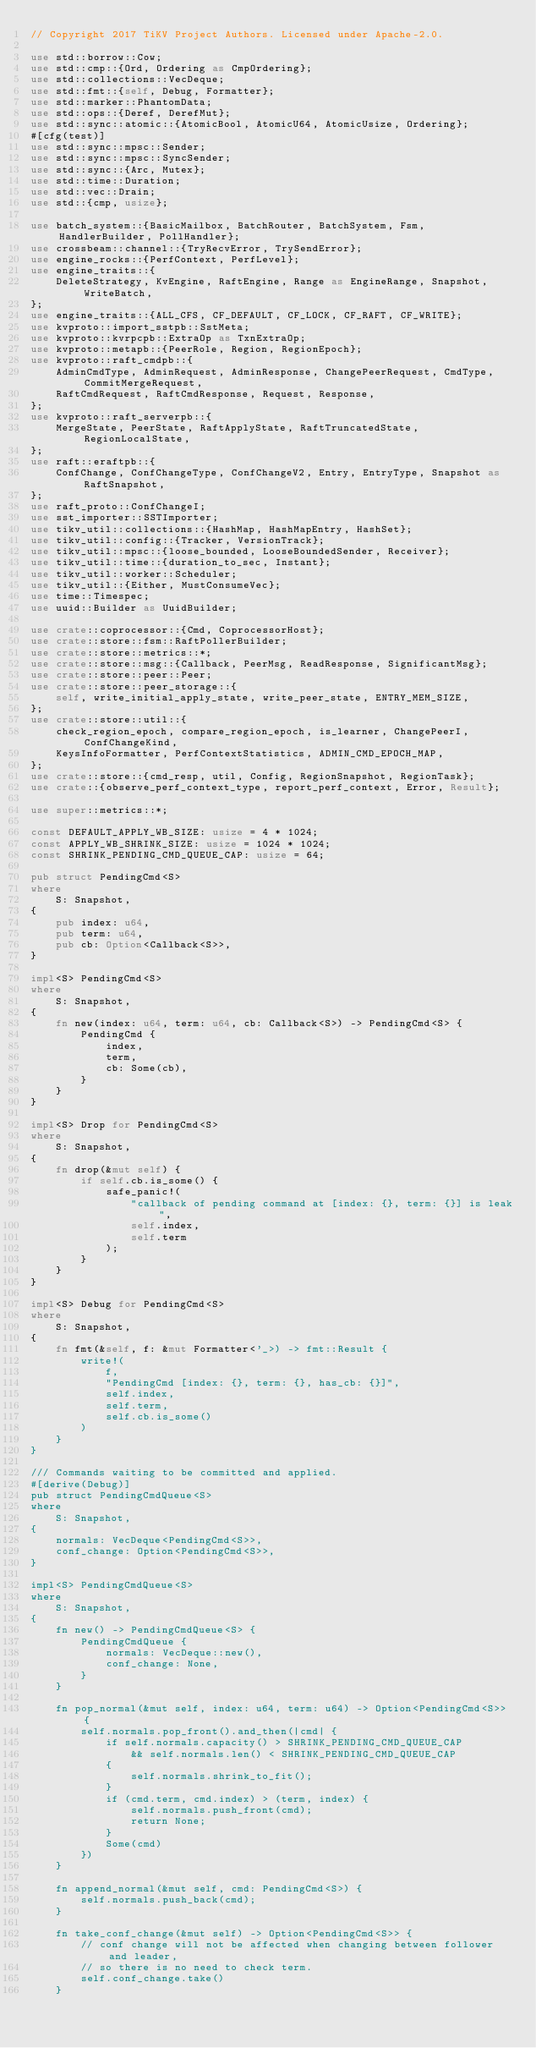<code> <loc_0><loc_0><loc_500><loc_500><_Rust_>// Copyright 2017 TiKV Project Authors. Licensed under Apache-2.0.

use std::borrow::Cow;
use std::cmp::{Ord, Ordering as CmpOrdering};
use std::collections::VecDeque;
use std::fmt::{self, Debug, Formatter};
use std::marker::PhantomData;
use std::ops::{Deref, DerefMut};
use std::sync::atomic::{AtomicBool, AtomicU64, AtomicUsize, Ordering};
#[cfg(test)]
use std::sync::mpsc::Sender;
use std::sync::mpsc::SyncSender;
use std::sync::{Arc, Mutex};
use std::time::Duration;
use std::vec::Drain;
use std::{cmp, usize};

use batch_system::{BasicMailbox, BatchRouter, BatchSystem, Fsm, HandlerBuilder, PollHandler};
use crossbeam::channel::{TryRecvError, TrySendError};
use engine_rocks::{PerfContext, PerfLevel};
use engine_traits::{
    DeleteStrategy, KvEngine, RaftEngine, Range as EngineRange, Snapshot, WriteBatch,
};
use engine_traits::{ALL_CFS, CF_DEFAULT, CF_LOCK, CF_RAFT, CF_WRITE};
use kvproto::import_sstpb::SstMeta;
use kvproto::kvrpcpb::ExtraOp as TxnExtraOp;
use kvproto::metapb::{PeerRole, Region, RegionEpoch};
use kvproto::raft_cmdpb::{
    AdminCmdType, AdminRequest, AdminResponse, ChangePeerRequest, CmdType, CommitMergeRequest,
    RaftCmdRequest, RaftCmdResponse, Request, Response,
};
use kvproto::raft_serverpb::{
    MergeState, PeerState, RaftApplyState, RaftTruncatedState, RegionLocalState,
};
use raft::eraftpb::{
    ConfChange, ConfChangeType, ConfChangeV2, Entry, EntryType, Snapshot as RaftSnapshot,
};
use raft_proto::ConfChangeI;
use sst_importer::SSTImporter;
use tikv_util::collections::{HashMap, HashMapEntry, HashSet};
use tikv_util::config::{Tracker, VersionTrack};
use tikv_util::mpsc::{loose_bounded, LooseBoundedSender, Receiver};
use tikv_util::time::{duration_to_sec, Instant};
use tikv_util::worker::Scheduler;
use tikv_util::{Either, MustConsumeVec};
use time::Timespec;
use uuid::Builder as UuidBuilder;

use crate::coprocessor::{Cmd, CoprocessorHost};
use crate::store::fsm::RaftPollerBuilder;
use crate::store::metrics::*;
use crate::store::msg::{Callback, PeerMsg, ReadResponse, SignificantMsg};
use crate::store::peer::Peer;
use crate::store::peer_storage::{
    self, write_initial_apply_state, write_peer_state, ENTRY_MEM_SIZE,
};
use crate::store::util::{
    check_region_epoch, compare_region_epoch, is_learner, ChangePeerI, ConfChangeKind,
    KeysInfoFormatter, PerfContextStatistics, ADMIN_CMD_EPOCH_MAP,
};
use crate::store::{cmd_resp, util, Config, RegionSnapshot, RegionTask};
use crate::{observe_perf_context_type, report_perf_context, Error, Result};

use super::metrics::*;

const DEFAULT_APPLY_WB_SIZE: usize = 4 * 1024;
const APPLY_WB_SHRINK_SIZE: usize = 1024 * 1024;
const SHRINK_PENDING_CMD_QUEUE_CAP: usize = 64;

pub struct PendingCmd<S>
where
    S: Snapshot,
{
    pub index: u64,
    pub term: u64,
    pub cb: Option<Callback<S>>,
}

impl<S> PendingCmd<S>
where
    S: Snapshot,
{
    fn new(index: u64, term: u64, cb: Callback<S>) -> PendingCmd<S> {
        PendingCmd {
            index,
            term,
            cb: Some(cb),
        }
    }
}

impl<S> Drop for PendingCmd<S>
where
    S: Snapshot,
{
    fn drop(&mut self) {
        if self.cb.is_some() {
            safe_panic!(
                "callback of pending command at [index: {}, term: {}] is leak",
                self.index,
                self.term
            );
        }
    }
}

impl<S> Debug for PendingCmd<S>
where
    S: Snapshot,
{
    fn fmt(&self, f: &mut Formatter<'_>) -> fmt::Result {
        write!(
            f,
            "PendingCmd [index: {}, term: {}, has_cb: {}]",
            self.index,
            self.term,
            self.cb.is_some()
        )
    }
}

/// Commands waiting to be committed and applied.
#[derive(Debug)]
pub struct PendingCmdQueue<S>
where
    S: Snapshot,
{
    normals: VecDeque<PendingCmd<S>>,
    conf_change: Option<PendingCmd<S>>,
}

impl<S> PendingCmdQueue<S>
where
    S: Snapshot,
{
    fn new() -> PendingCmdQueue<S> {
        PendingCmdQueue {
            normals: VecDeque::new(),
            conf_change: None,
        }
    }

    fn pop_normal(&mut self, index: u64, term: u64) -> Option<PendingCmd<S>> {
        self.normals.pop_front().and_then(|cmd| {
            if self.normals.capacity() > SHRINK_PENDING_CMD_QUEUE_CAP
                && self.normals.len() < SHRINK_PENDING_CMD_QUEUE_CAP
            {
                self.normals.shrink_to_fit();
            }
            if (cmd.term, cmd.index) > (term, index) {
                self.normals.push_front(cmd);
                return None;
            }
            Some(cmd)
        })
    }

    fn append_normal(&mut self, cmd: PendingCmd<S>) {
        self.normals.push_back(cmd);
    }

    fn take_conf_change(&mut self) -> Option<PendingCmd<S>> {
        // conf change will not be affected when changing between follower and leader,
        // so there is no need to check term.
        self.conf_change.take()
    }
</code> 